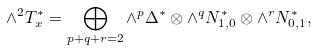Convert formula to latex. <formula><loc_0><loc_0><loc_500><loc_500>\wedge ^ { 2 } T ^ { * } _ { x } = \bigoplus _ { p + q + r = 2 } \wedge ^ { p } \Delta ^ { * } \otimes \wedge ^ { q } N ^ { * } _ { 1 , 0 } \otimes \wedge ^ { r } N ^ { * } _ { 0 , 1 } ,</formula> 